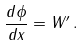Convert formula to latex. <formula><loc_0><loc_0><loc_500><loc_500>\frac { d \phi } { d x } = W ^ { \prime } \, .</formula> 